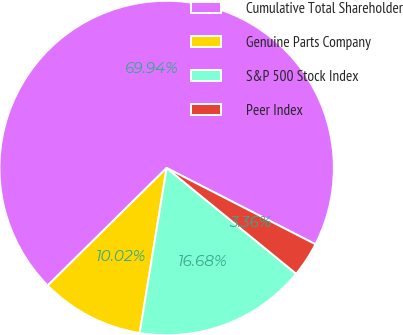Convert chart. <chart><loc_0><loc_0><loc_500><loc_500><pie_chart><fcel>Cumulative Total Shareholder<fcel>Genuine Parts Company<fcel>S&P 500 Stock Index<fcel>Peer Index<nl><fcel>69.95%<fcel>10.02%<fcel>16.68%<fcel>3.36%<nl></chart> 